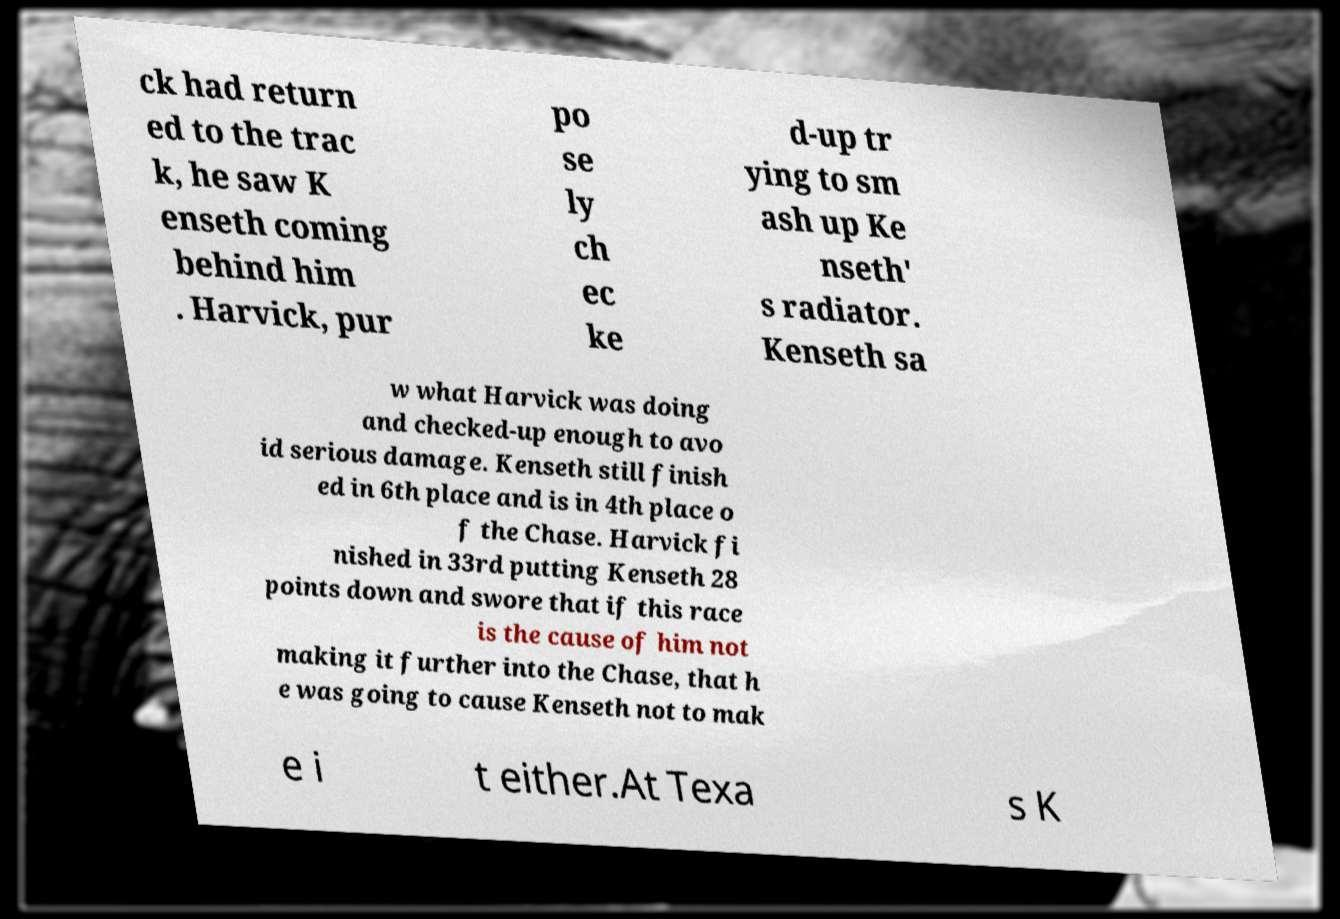Can you accurately transcribe the text from the provided image for me? ck had return ed to the trac k, he saw K enseth coming behind him . Harvick, pur po se ly ch ec ke d-up tr ying to sm ash up Ke nseth' s radiator. Kenseth sa w what Harvick was doing and checked-up enough to avo id serious damage. Kenseth still finish ed in 6th place and is in 4th place o f the Chase. Harvick fi nished in 33rd putting Kenseth 28 points down and swore that if this race is the cause of him not making it further into the Chase, that h e was going to cause Kenseth not to mak e i t either.At Texa s K 